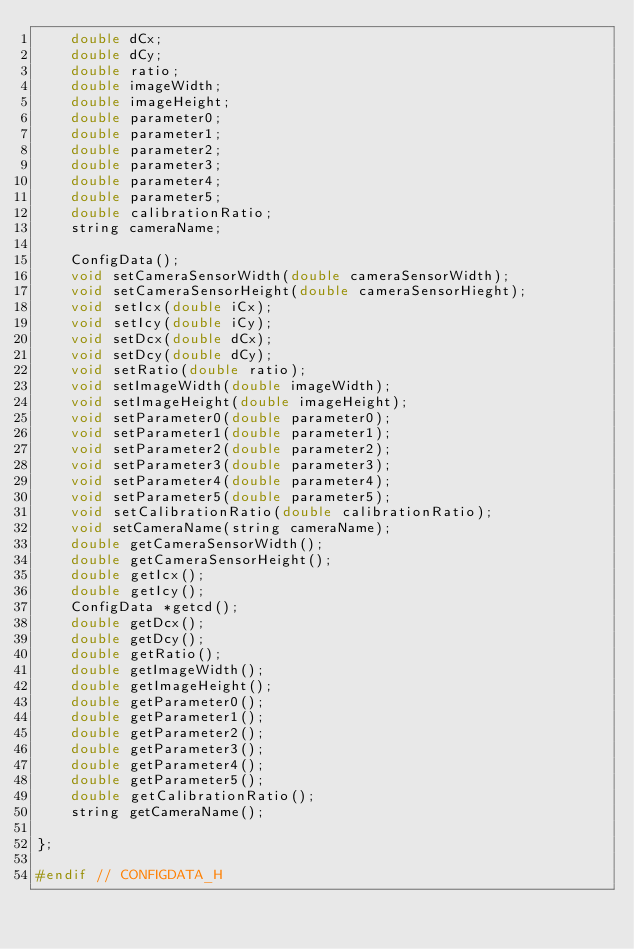Convert code to text. <code><loc_0><loc_0><loc_500><loc_500><_C_>    double dCx;
    double dCy;
    double ratio;
    double imageWidth;
    double imageHeight;
    double parameter0;
    double parameter1;
    double parameter2;
    double parameter3;
    double parameter4;
    double parameter5;
    double calibrationRatio;
    string cameraName;

    ConfigData();
    void setCameraSensorWidth(double cameraSensorWidth);
    void setCameraSensorHeight(double cameraSensorHieght);
    void setIcx(double iCx);
    void setIcy(double iCy);
    void setDcx(double dCx);
    void setDcy(double dCy);
    void setRatio(double ratio);
    void setImageWidth(double imageWidth);
    void setImageHeight(double imageHeight);
    void setParameter0(double parameter0);
    void setParameter1(double parameter1);
    void setParameter2(double parameter2);
    void setParameter3(double parameter3);
    void setParameter4(double parameter4);
    void setParameter5(double parameter5);
    void setCalibrationRatio(double calibrationRatio);
    void setCameraName(string cameraName);
    double getCameraSensorWidth();
    double getCameraSensorHeight();
    double getIcx();
    double getIcy();
    ConfigData *getcd();
    double getDcx();
    double getDcy();
    double getRatio();
    double getImageWidth();
    double getImageHeight();
    double getParameter0();
    double getParameter1();
    double getParameter2();
    double getParameter3();
    double getParameter4();
    double getParameter5();
    double getCalibrationRatio();
    string getCameraName();

};

#endif // CONFIGDATA_H
</code> 